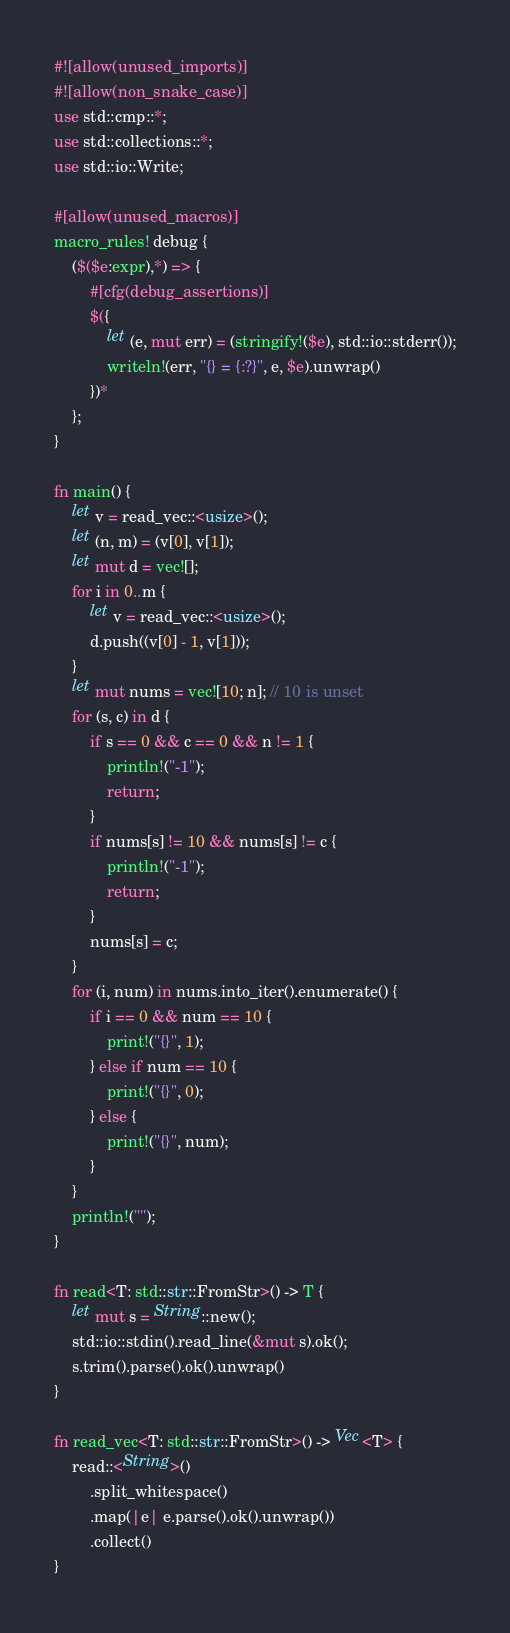Convert code to text. <code><loc_0><loc_0><loc_500><loc_500><_Rust_>#![allow(unused_imports)]
#![allow(non_snake_case)]
use std::cmp::*;
use std::collections::*;
use std::io::Write;

#[allow(unused_macros)]
macro_rules! debug {
    ($($e:expr),*) => {
        #[cfg(debug_assertions)]
        $({
            let (e, mut err) = (stringify!($e), std::io::stderr());
            writeln!(err, "{} = {:?}", e, $e).unwrap()
        })*
    };
}

fn main() {
    let v = read_vec::<usize>();
    let (n, m) = (v[0], v[1]);
    let mut d = vec![];
    for i in 0..m {
        let v = read_vec::<usize>();
        d.push((v[0] - 1, v[1]));
    }
    let mut nums = vec![10; n]; // 10 is unset
    for (s, c) in d {
        if s == 0 && c == 0 && n != 1 {
            println!("-1");
            return;
        }
        if nums[s] != 10 && nums[s] != c {
            println!("-1");
            return;
        }
        nums[s] = c;
    }
    for (i, num) in nums.into_iter().enumerate() {
        if i == 0 && num == 10 {
            print!("{}", 1);
        } else if num == 10 {
            print!("{}", 0);
        } else {
            print!("{}", num);
        }
    }
    println!("");
}

fn read<T: std::str::FromStr>() -> T {
    let mut s = String::new();
    std::io::stdin().read_line(&mut s).ok();
    s.trim().parse().ok().unwrap()
}

fn read_vec<T: std::str::FromStr>() -> Vec<T> {
    read::<String>()
        .split_whitespace()
        .map(|e| e.parse().ok().unwrap())
        .collect()
}
</code> 